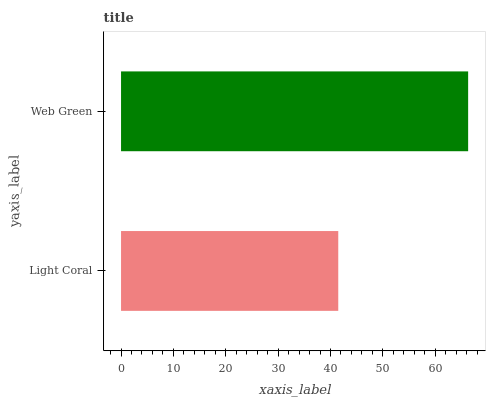Is Light Coral the minimum?
Answer yes or no. Yes. Is Web Green the maximum?
Answer yes or no. Yes. Is Web Green the minimum?
Answer yes or no. No. Is Web Green greater than Light Coral?
Answer yes or no. Yes. Is Light Coral less than Web Green?
Answer yes or no. Yes. Is Light Coral greater than Web Green?
Answer yes or no. No. Is Web Green less than Light Coral?
Answer yes or no. No. Is Web Green the high median?
Answer yes or no. Yes. Is Light Coral the low median?
Answer yes or no. Yes. Is Light Coral the high median?
Answer yes or no. No. Is Web Green the low median?
Answer yes or no. No. 